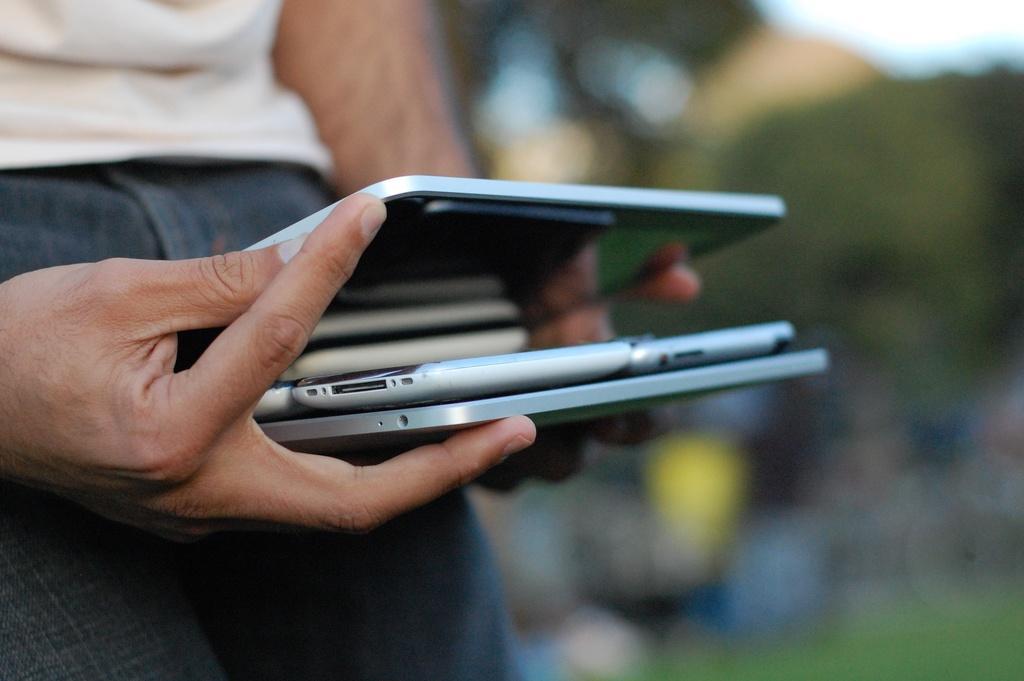Can you describe this image briefly? In this picture we can see a person holding devices and in the background it is blurry. 